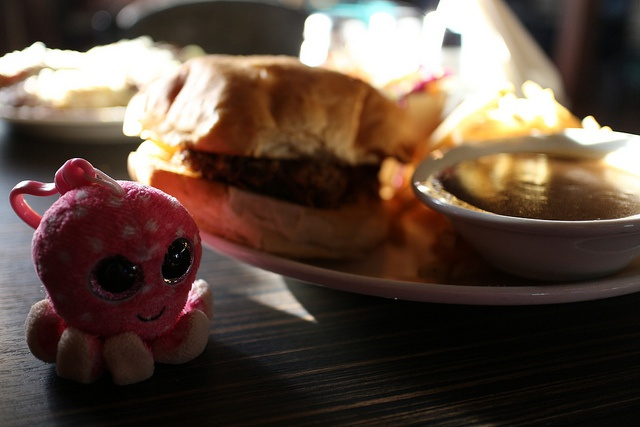Describe the objects in this image and their specific colors. I can see dining table in black, gray, and darkgray tones, hot dog in black, maroon, ivory, and brown tones, sandwich in black, maroon, ivory, and brown tones, bowl in black, maroon, and ivory tones, and sandwich in black, white, and tan tones in this image. 